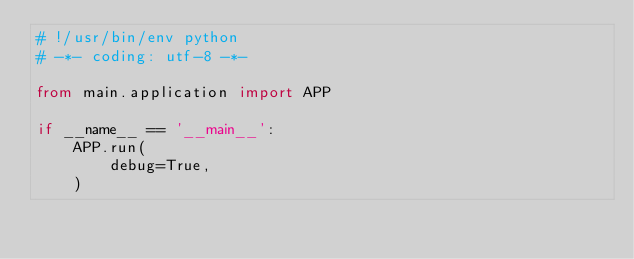Convert code to text. <code><loc_0><loc_0><loc_500><loc_500><_Python_># !/usr/bin/env python
# -*- coding: utf-8 -*-

from main.application import APP

if __name__ == '__main__':
    APP.run(
        debug=True,
    )</code> 